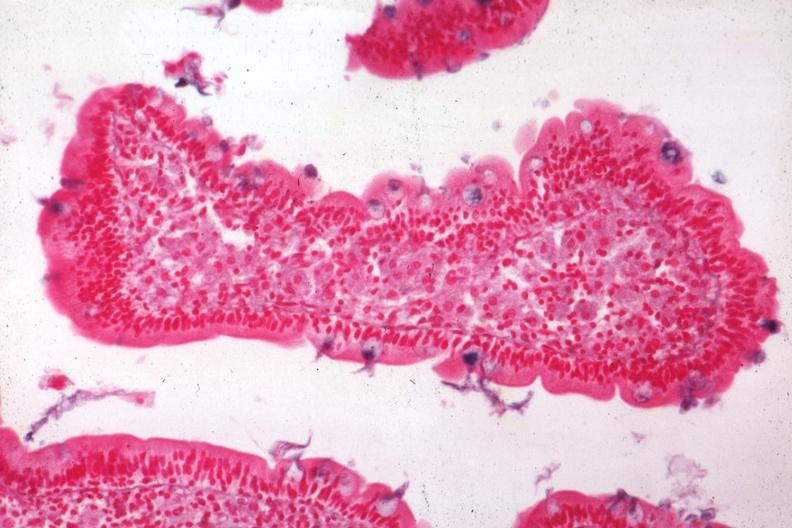what is present?
Answer the question using a single word or phrase. Intestine 